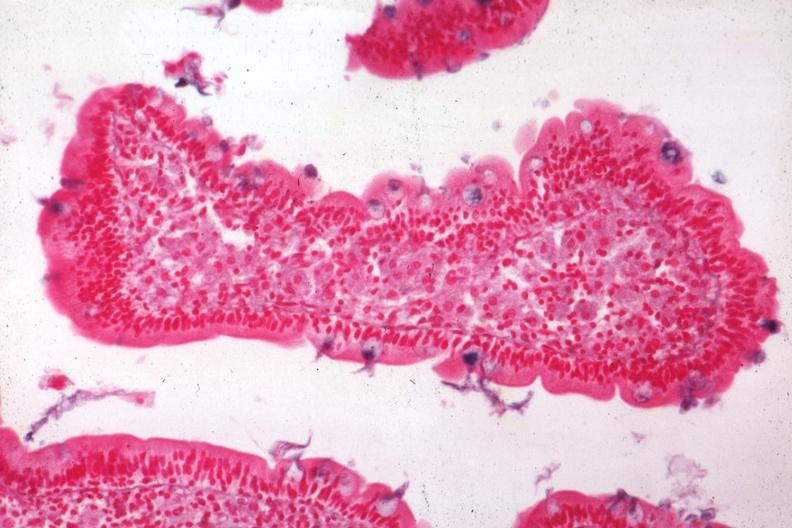what is present?
Answer the question using a single word or phrase. Intestine 